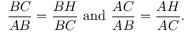Convert formula to latex. <formula><loc_0><loc_0><loc_500><loc_500>{ \frac { B C } { A B } } = { \frac { B H } { B C } } { a n d } { \frac { A C } { A B } } = { \frac { A H } { A C } } .</formula> 